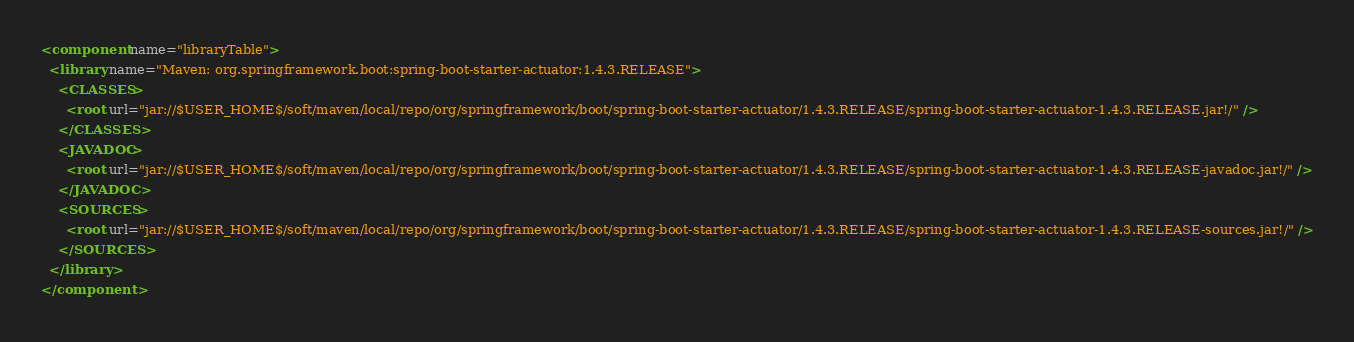<code> <loc_0><loc_0><loc_500><loc_500><_XML_><component name="libraryTable">
  <library name="Maven: org.springframework.boot:spring-boot-starter-actuator:1.4.3.RELEASE">
    <CLASSES>
      <root url="jar://$USER_HOME$/soft/maven/local/repo/org/springframework/boot/spring-boot-starter-actuator/1.4.3.RELEASE/spring-boot-starter-actuator-1.4.3.RELEASE.jar!/" />
    </CLASSES>
    <JAVADOC>
      <root url="jar://$USER_HOME$/soft/maven/local/repo/org/springframework/boot/spring-boot-starter-actuator/1.4.3.RELEASE/spring-boot-starter-actuator-1.4.3.RELEASE-javadoc.jar!/" />
    </JAVADOC>
    <SOURCES>
      <root url="jar://$USER_HOME$/soft/maven/local/repo/org/springframework/boot/spring-boot-starter-actuator/1.4.3.RELEASE/spring-boot-starter-actuator-1.4.3.RELEASE-sources.jar!/" />
    </SOURCES>
  </library>
</component></code> 